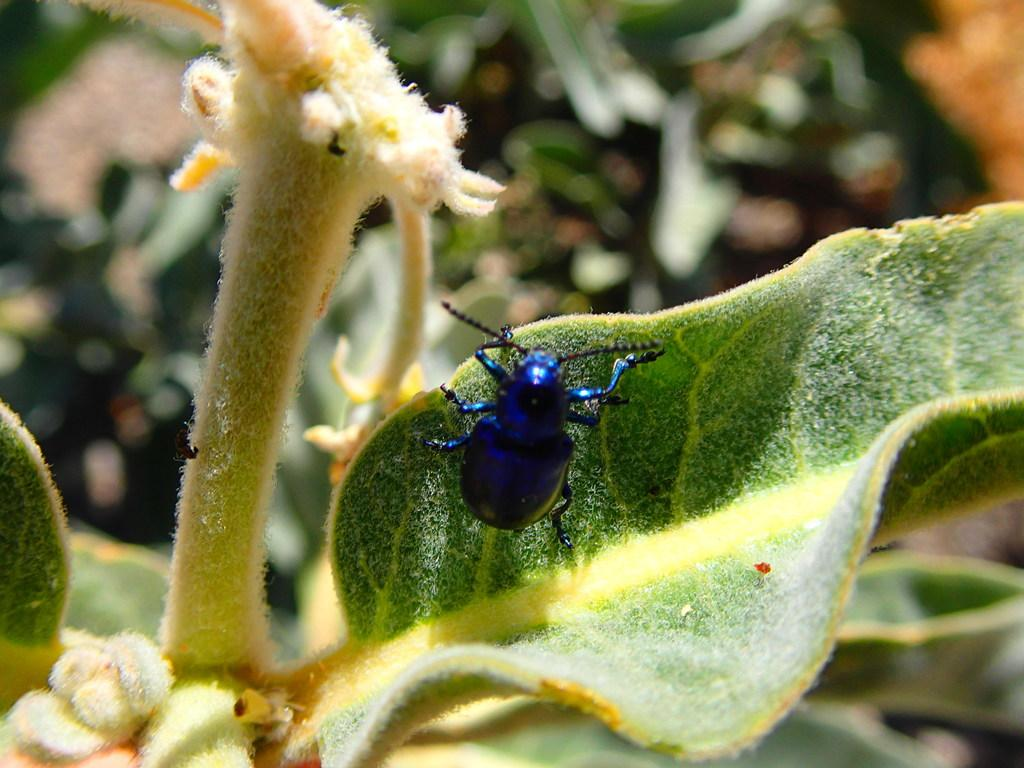What type of creature is present in the image? There is an insect in the image. Where is the insect located? The insect is on a leaf. Can you describe the background of the image? The background of the image is blurred. How many men are wearing mittens in the image? There are no men or mittens present in the image; it features an insect on a leaf. What type of interest does the insect have in the image? The image does not provide information about the insect's interests. 